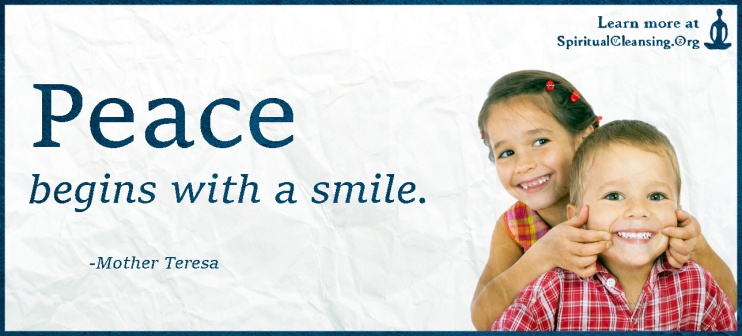What do you think the children in the photo might be thinking or feeling in this moment? The children in the photograph appear to be experiencing pure joy and delight. Their broad, genuine smiles suggest that they are fully immersed in a moment of playful fun and mutual enjoyment. The girl, with twinkling eyes and a laugh that seems to be on the verge of breaking out, might be feeling a sense of camaraderie and happiness while engaging with her fellow playmate. The boy, whose mischievous grin complements his bright demeanor, might be feeling equally happy and entertained. In this shared moment, they could be feeling a deep sense of connection and uninhibited joy, embodying the innocence and carefree nature often associated with childhood. If these children were to give out advice on happiness, what do you think they might say? If the children were to give advice on happiness, they might say something endearingly simple yet profoundly meaningful. They could suggest, 'Just be yourself and have fun with your friends!' or 'Find something to laugh about every day!' They might also emphasize the importance of play and genuine connection, saying, 'Spend time with the people you love and do things that make you smile.' Their advice would likely be straightforward, reflecting their innate understanding that happiness often comes from enjoying the small, precious moments in life and sharing them with others. 